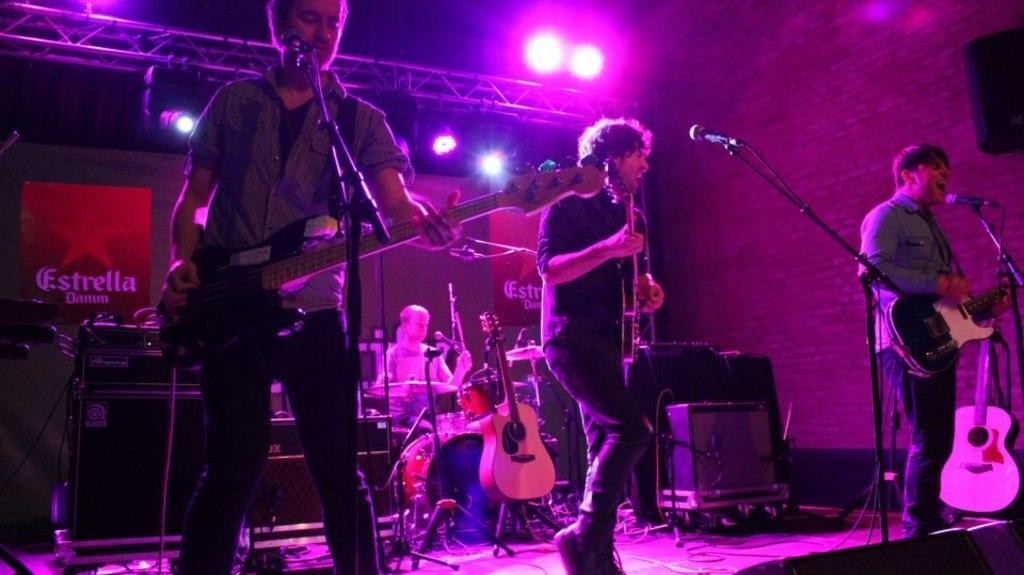Could you give a brief overview of what you see in this image? 4 people are present. at the front 3 people are playing guitar and singing in front of microphones. at the back, a person is playing drums. behind, a banner is placed on which estreem is written. 